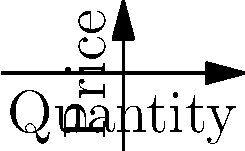Given the marginal cost (MC) and marginal revenue (MR) curves shown in the graph, determine the profit-maximizing quantity of production and explain why this point (labeled A) represents the optimal production level. How would you advise a firm to use this information in their production decisions? To determine the profit-maximizing quantity and explain why point A represents the optimal production level, we'll follow these steps:

1) Profit maximization occurs where Marginal Revenue (MR) equals Marginal Cost (MC). This is represented by point A in the graph.

2) At point A, we can see that:
   - The quantity produced is 4 units
   - The price (which equals MR at this point) is 10

3) To verify this mathematically:
   - MC curve equation: $MC = 0.5x^2 + 2$
   - MR curve equation: $MR = -0.25x^2 + 10$

4) At the optimal point, MC = MR:
   $0.5x^2 + 2 = -0.25x^2 + 10$
   $0.75x^2 = 8$
   $x^2 = \frac{32}{3}$
   $x = \sqrt{\frac{32}{3}} \approx 3.27$

5) This confirms that the optimal quantity is approximately 4 units (given the graph's scale).

6) Why is this the optimal production level?
   - For any quantity less than 4, MR > MC, so producing more would increase profit.
   - For any quantity greater than 4, MC > MR, so producing less would increase profit.
   - At exactly 4 units, the additional revenue from the last unit equals its additional cost, maximizing profit.

7) Advice for the firm:
   - Produce up to the point where MC = MR (4 units in this case).
   - Continuously monitor MC and MR, adjusting production if market conditions change.
   - Use this analysis as a starting point, but consider other factors like fixed costs, competitor behavior, and long-term strategy.
Answer: Produce 4 units where MC = MR to maximize profit. 